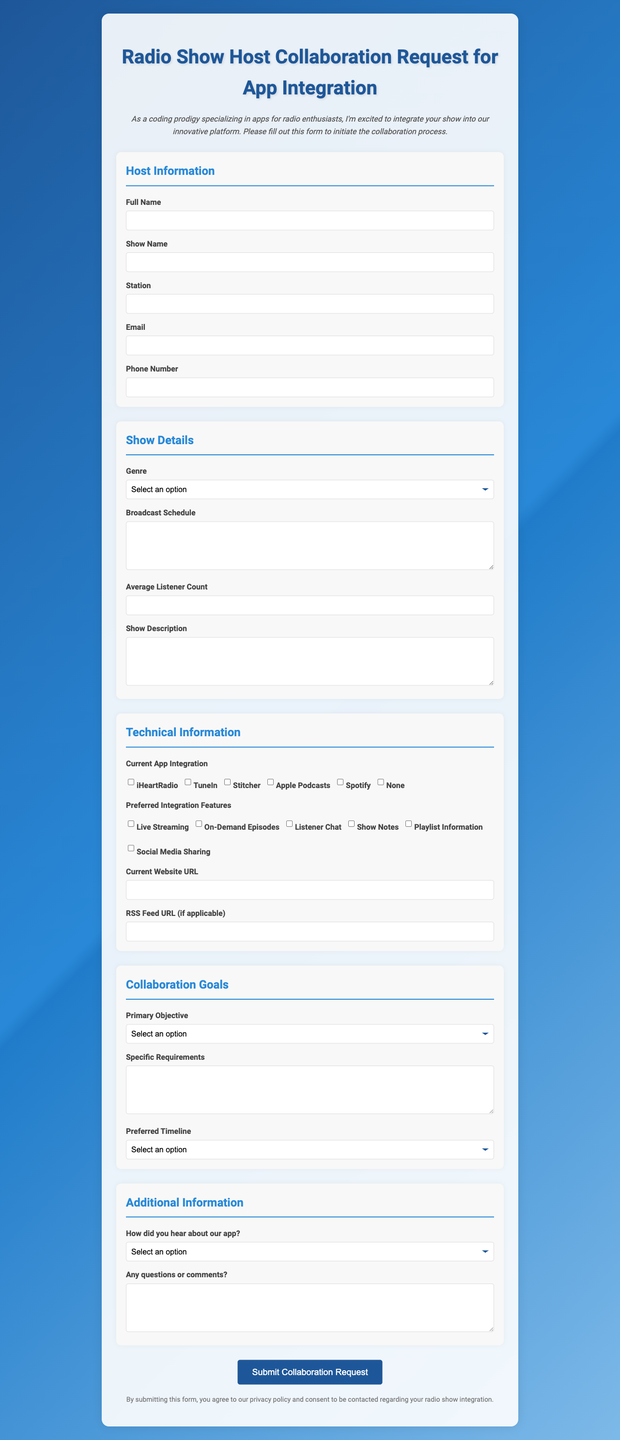What is the title of the form? The title of the form is indicated at the top of the document, which serves as the main heading.
Answer: Radio Show Host Collaboration Request for App Integration What type of information is required in the Host Information section? The Host Information section contains various fields for the host's essential details, with certain fields marked as required.
Answer: Full Name, Show Name, Station, Email What genres can a radio show choose from? The Show Details section provides a list of genres available for selection.
Answer: Talk Radio, Music, News, Sports, Comedy, True Crime, Other What is the submit button text? The document specifies what text should be displayed on the button used to submit the form.
Answer: Submit Collaboration Request Which checkbox options are provided for Current App Integration? The Technical Information section lists options regarding existing app integrations, available for selection via checkboxes.
Answer: iHeartRadio, TuneIn, Stitcher, Apple Podcasts, Spotify, None What is the primary objective for collaboration? The Collaboration Goals section asks the submitter to select their main goal for the collaboration from a predefined list.
Answer: Increase Listener Base, Improve Listener Engagement, Monetization, Cross-Promotion, Technical Upgrade, Other How did the submitter hear about the app? The Additional Information section includes an optional field asking the submitter about their source of information regarding the app.
Answer: Word of mouth, Social media, Radio industry event, Online advertisement, Other What is the privacy notice regarding the form submission? The document includes a privacy notice indicating what the submitter agrees to by filling out the form.
Answer: By submitting this form, you agree to our privacy policy and consent to be contacted regarding your radio show integration 